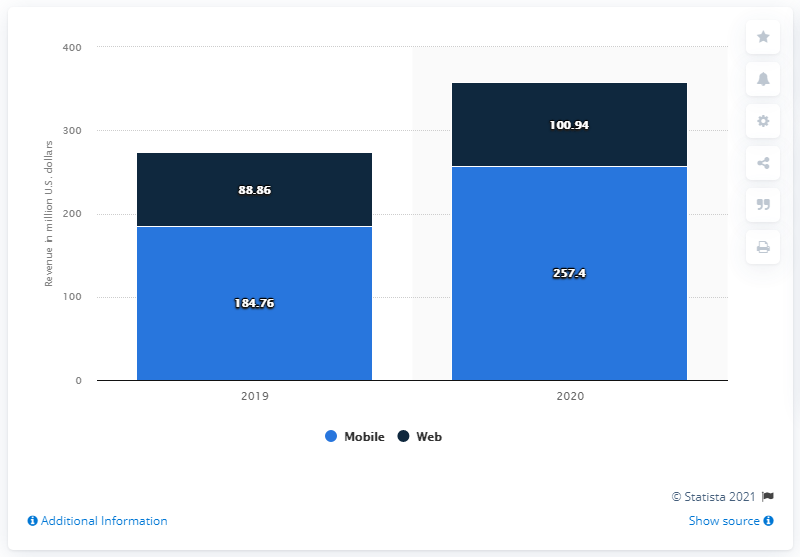Outline some significant characteristics in this image. In 2020, DoubleDown Interactive generated $257.4 million in revenue through mobile platforms. In 2020, DoubleDown Interactive generated $100.94 million in non-mobile revenues. 